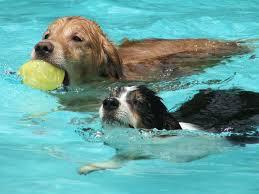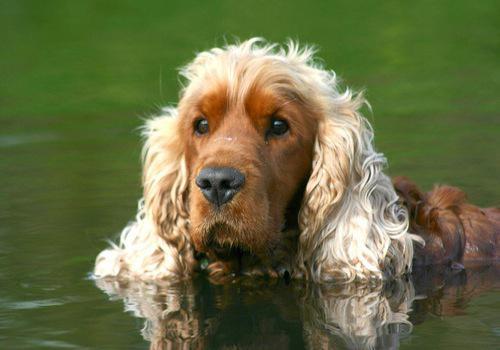The first image is the image on the left, the second image is the image on the right. Given the left and right images, does the statement "In one of the images, there is a dog swimming while carrying an object in its mouth." hold true? Answer yes or no. Yes. 